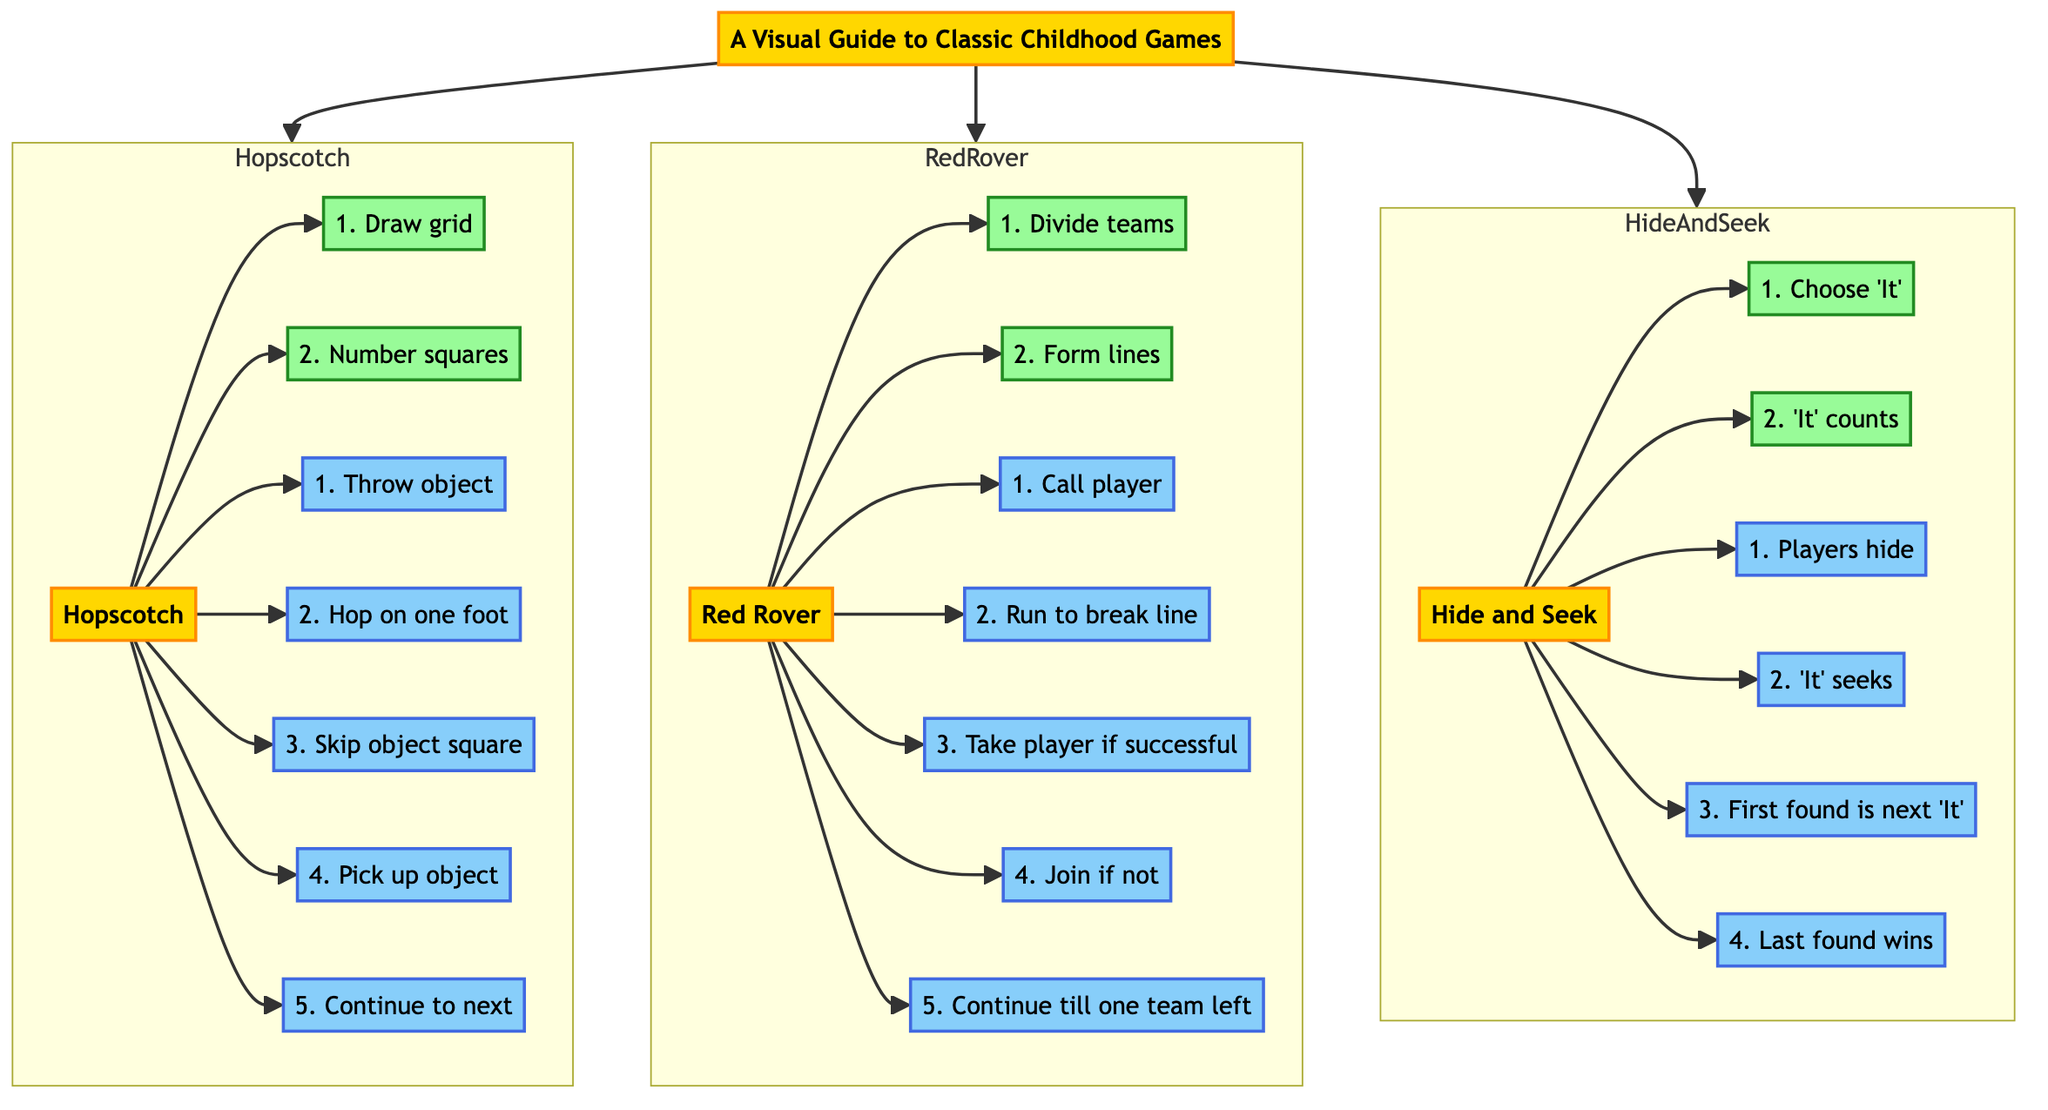What is the first step in Hopscotch? The first step in the Hopscotch game is to "Draw grid," which is clearly indicated as the first setup node connected to the Hopscotch game node.
Answer: Draw grid How many rules are there in Red Rover? The Red Rover game has five rules, which can be counted from the connected rule nodes under the Red Rover subgraph.
Answer: 5 What do players do when they are found in Hide and Seek? The rule states that "First found is next 'It'," meaning the player who is found takes on the role of 'It' in the next round.
Answer: First found is next 'It' Which game requires teams to divide? The game "Red Rover" requires teams to divide, as indicated in the setup nodes connected to the Red Rover game node.
Answer: Red Rover How many steps are in Hide and Seek? Hide and Seek has a total of four rules, which are listed under the rule nodes connected to the Hide and Seek game node.
Answer: 4 Which games involve hopping? The game "Hopscotch" involves hopping, as indicated by the rule "Hop on one foot." This directly links the action of hopping to this specific game.
Answer: Hopscotch What is the last step in Red Rover? The last step listed in the Red Rover game rules is "Continue till one team left," which concludes the sequence of rules for this game.
Answer: Continue till one team left How is the first action in Hide and Seek initiated? In Hide and Seek, the first action is initiated by choosing 'It' as indicated in the setup steps, specifically the step "Choose 'It'."
Answer: Choose 'It' 